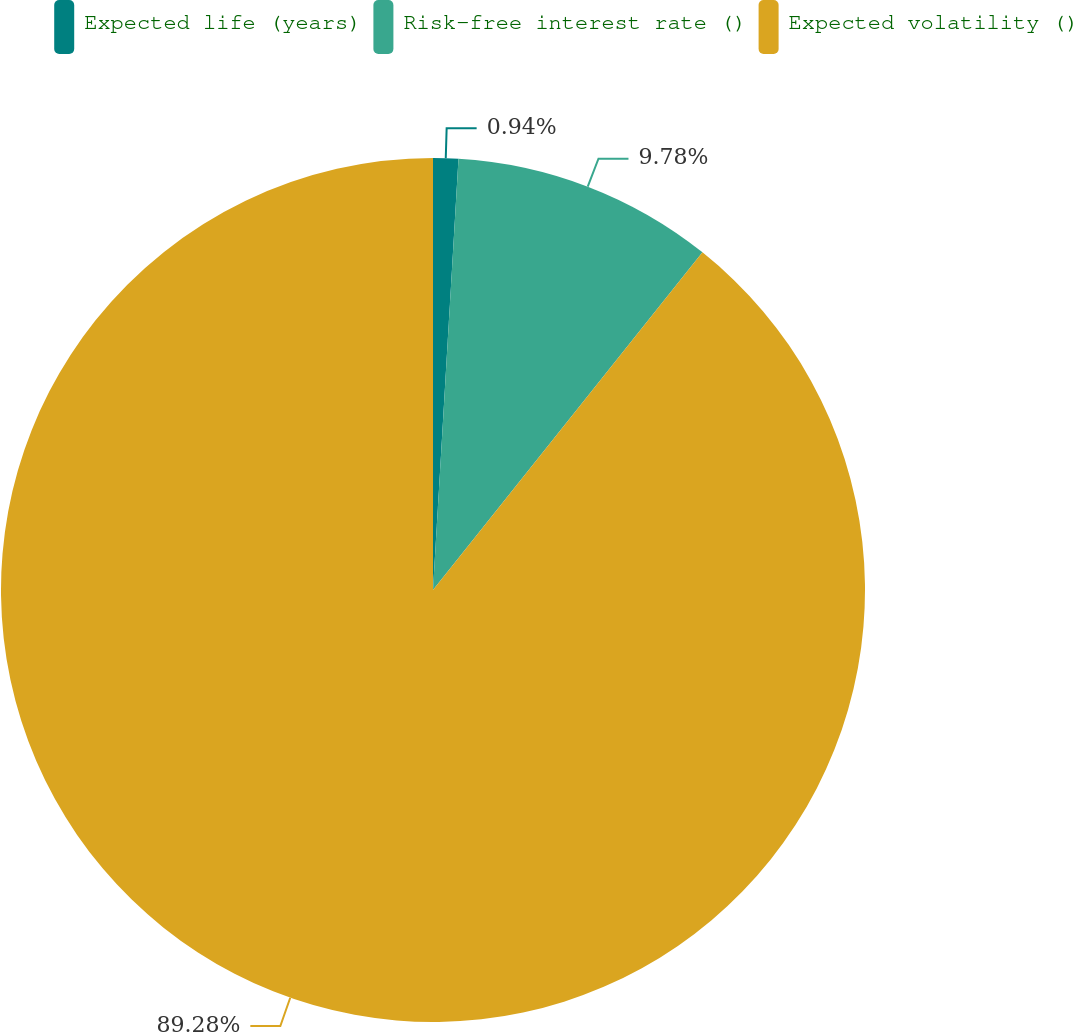<chart> <loc_0><loc_0><loc_500><loc_500><pie_chart><fcel>Expected life (years)<fcel>Risk-free interest rate ()<fcel>Expected volatility ()<nl><fcel>0.94%<fcel>9.78%<fcel>89.28%<nl></chart> 